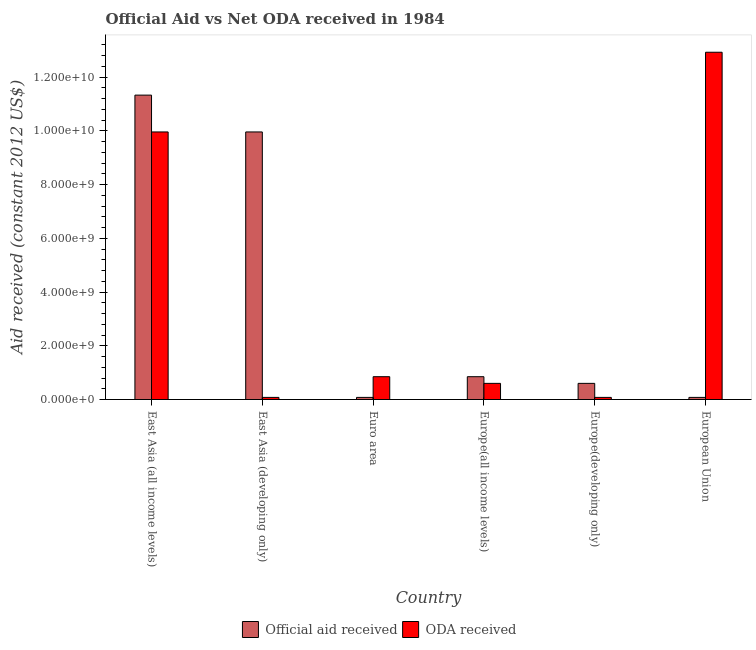How many different coloured bars are there?
Your response must be concise. 2. How many bars are there on the 4th tick from the left?
Your answer should be very brief. 2. In how many cases, is the number of bars for a given country not equal to the number of legend labels?
Make the answer very short. 0. What is the official aid received in Euro area?
Your answer should be very brief. 7.91e+07. Across all countries, what is the maximum oda received?
Your answer should be very brief. 1.29e+1. Across all countries, what is the minimum oda received?
Provide a succinct answer. 7.91e+07. In which country was the oda received maximum?
Your answer should be very brief. European Union. What is the total oda received in the graph?
Ensure brevity in your answer.  2.45e+1. What is the difference between the official aid received in East Asia (all income levels) and that in Europe(developing only)?
Keep it short and to the point. 1.07e+1. What is the average official aid received per country?
Offer a terse response. 3.82e+09. What is the difference between the official aid received and oda received in Euro area?
Offer a terse response. -7.70e+08. In how many countries, is the official aid received greater than 1600000000 US$?
Offer a terse response. 2. What is the ratio of the oda received in East Asia (developing only) to that in Europe(all income levels)?
Your answer should be very brief. 0.13. What is the difference between the highest and the second highest official aid received?
Give a very brief answer. 1.37e+09. What is the difference between the highest and the lowest oda received?
Offer a terse response. 1.28e+1. In how many countries, is the official aid received greater than the average official aid received taken over all countries?
Make the answer very short. 2. Is the sum of the oda received in East Asia (all income levels) and East Asia (developing only) greater than the maximum official aid received across all countries?
Your answer should be compact. No. What does the 2nd bar from the left in East Asia (all income levels) represents?
Provide a short and direct response. ODA received. What does the 2nd bar from the right in East Asia (developing only) represents?
Offer a very short reply. Official aid received. How many bars are there?
Your answer should be compact. 12. Are all the bars in the graph horizontal?
Your answer should be compact. No. Are the values on the major ticks of Y-axis written in scientific E-notation?
Your answer should be very brief. Yes. Does the graph contain grids?
Ensure brevity in your answer.  No. Where does the legend appear in the graph?
Offer a terse response. Bottom center. How many legend labels are there?
Offer a very short reply. 2. How are the legend labels stacked?
Your answer should be very brief. Horizontal. What is the title of the graph?
Your answer should be compact. Official Aid vs Net ODA received in 1984 . What is the label or title of the X-axis?
Your response must be concise. Country. What is the label or title of the Y-axis?
Keep it short and to the point. Aid received (constant 2012 US$). What is the Aid received (constant 2012 US$) of Official aid received in East Asia (all income levels)?
Offer a very short reply. 1.13e+1. What is the Aid received (constant 2012 US$) in ODA received in East Asia (all income levels)?
Your answer should be compact. 9.96e+09. What is the Aid received (constant 2012 US$) in Official aid received in East Asia (developing only)?
Give a very brief answer. 9.96e+09. What is the Aid received (constant 2012 US$) in ODA received in East Asia (developing only)?
Keep it short and to the point. 7.91e+07. What is the Aid received (constant 2012 US$) in Official aid received in Euro area?
Your response must be concise. 7.91e+07. What is the Aid received (constant 2012 US$) in ODA received in Euro area?
Offer a very short reply. 8.49e+08. What is the Aid received (constant 2012 US$) in Official aid received in Europe(all income levels)?
Your answer should be very brief. 8.49e+08. What is the Aid received (constant 2012 US$) of ODA received in Europe(all income levels)?
Provide a succinct answer. 6.01e+08. What is the Aid received (constant 2012 US$) of Official aid received in Europe(developing only)?
Your answer should be very brief. 6.01e+08. What is the Aid received (constant 2012 US$) in ODA received in Europe(developing only)?
Your answer should be very brief. 7.91e+07. What is the Aid received (constant 2012 US$) in Official aid received in European Union?
Your response must be concise. 7.91e+07. What is the Aid received (constant 2012 US$) in ODA received in European Union?
Ensure brevity in your answer.  1.29e+1. Across all countries, what is the maximum Aid received (constant 2012 US$) of Official aid received?
Ensure brevity in your answer.  1.13e+1. Across all countries, what is the maximum Aid received (constant 2012 US$) in ODA received?
Offer a very short reply. 1.29e+1. Across all countries, what is the minimum Aid received (constant 2012 US$) in Official aid received?
Your answer should be compact. 7.91e+07. Across all countries, what is the minimum Aid received (constant 2012 US$) of ODA received?
Ensure brevity in your answer.  7.91e+07. What is the total Aid received (constant 2012 US$) of Official aid received in the graph?
Offer a terse response. 2.29e+1. What is the total Aid received (constant 2012 US$) of ODA received in the graph?
Offer a very short reply. 2.45e+1. What is the difference between the Aid received (constant 2012 US$) in Official aid received in East Asia (all income levels) and that in East Asia (developing only)?
Give a very brief answer. 1.37e+09. What is the difference between the Aid received (constant 2012 US$) in ODA received in East Asia (all income levels) and that in East Asia (developing only)?
Your response must be concise. 9.88e+09. What is the difference between the Aid received (constant 2012 US$) of Official aid received in East Asia (all income levels) and that in Euro area?
Keep it short and to the point. 1.12e+1. What is the difference between the Aid received (constant 2012 US$) of ODA received in East Asia (all income levels) and that in Euro area?
Ensure brevity in your answer.  9.11e+09. What is the difference between the Aid received (constant 2012 US$) of Official aid received in East Asia (all income levels) and that in Europe(all income levels)?
Make the answer very short. 1.05e+1. What is the difference between the Aid received (constant 2012 US$) of ODA received in East Asia (all income levels) and that in Europe(all income levels)?
Your answer should be very brief. 9.35e+09. What is the difference between the Aid received (constant 2012 US$) of Official aid received in East Asia (all income levels) and that in Europe(developing only)?
Provide a succinct answer. 1.07e+1. What is the difference between the Aid received (constant 2012 US$) in ODA received in East Asia (all income levels) and that in Europe(developing only)?
Offer a terse response. 9.88e+09. What is the difference between the Aid received (constant 2012 US$) in Official aid received in East Asia (all income levels) and that in European Union?
Offer a terse response. 1.12e+1. What is the difference between the Aid received (constant 2012 US$) in ODA received in East Asia (all income levels) and that in European Union?
Offer a very short reply. -2.97e+09. What is the difference between the Aid received (constant 2012 US$) of Official aid received in East Asia (developing only) and that in Euro area?
Offer a very short reply. 9.88e+09. What is the difference between the Aid received (constant 2012 US$) in ODA received in East Asia (developing only) and that in Euro area?
Your response must be concise. -7.70e+08. What is the difference between the Aid received (constant 2012 US$) in Official aid received in East Asia (developing only) and that in Europe(all income levels)?
Provide a short and direct response. 9.11e+09. What is the difference between the Aid received (constant 2012 US$) in ODA received in East Asia (developing only) and that in Europe(all income levels)?
Offer a terse response. -5.22e+08. What is the difference between the Aid received (constant 2012 US$) in Official aid received in East Asia (developing only) and that in Europe(developing only)?
Your answer should be compact. 9.35e+09. What is the difference between the Aid received (constant 2012 US$) of ODA received in East Asia (developing only) and that in Europe(developing only)?
Your response must be concise. 0. What is the difference between the Aid received (constant 2012 US$) of Official aid received in East Asia (developing only) and that in European Union?
Your answer should be compact. 9.88e+09. What is the difference between the Aid received (constant 2012 US$) of ODA received in East Asia (developing only) and that in European Union?
Your answer should be compact. -1.28e+1. What is the difference between the Aid received (constant 2012 US$) of Official aid received in Euro area and that in Europe(all income levels)?
Keep it short and to the point. -7.70e+08. What is the difference between the Aid received (constant 2012 US$) in ODA received in Euro area and that in Europe(all income levels)?
Keep it short and to the point. 2.48e+08. What is the difference between the Aid received (constant 2012 US$) in Official aid received in Euro area and that in Europe(developing only)?
Your answer should be very brief. -5.22e+08. What is the difference between the Aid received (constant 2012 US$) in ODA received in Euro area and that in Europe(developing only)?
Ensure brevity in your answer.  7.70e+08. What is the difference between the Aid received (constant 2012 US$) of Official aid received in Euro area and that in European Union?
Offer a very short reply. 0. What is the difference between the Aid received (constant 2012 US$) in ODA received in Euro area and that in European Union?
Your answer should be very brief. -1.21e+1. What is the difference between the Aid received (constant 2012 US$) in Official aid received in Europe(all income levels) and that in Europe(developing only)?
Your response must be concise. 2.48e+08. What is the difference between the Aid received (constant 2012 US$) in ODA received in Europe(all income levels) and that in Europe(developing only)?
Provide a succinct answer. 5.22e+08. What is the difference between the Aid received (constant 2012 US$) in Official aid received in Europe(all income levels) and that in European Union?
Your response must be concise. 7.70e+08. What is the difference between the Aid received (constant 2012 US$) in ODA received in Europe(all income levels) and that in European Union?
Give a very brief answer. -1.23e+1. What is the difference between the Aid received (constant 2012 US$) of Official aid received in Europe(developing only) and that in European Union?
Your answer should be compact. 5.22e+08. What is the difference between the Aid received (constant 2012 US$) in ODA received in Europe(developing only) and that in European Union?
Offer a terse response. -1.28e+1. What is the difference between the Aid received (constant 2012 US$) of Official aid received in East Asia (all income levels) and the Aid received (constant 2012 US$) of ODA received in East Asia (developing only)?
Provide a short and direct response. 1.12e+1. What is the difference between the Aid received (constant 2012 US$) in Official aid received in East Asia (all income levels) and the Aid received (constant 2012 US$) in ODA received in Euro area?
Offer a terse response. 1.05e+1. What is the difference between the Aid received (constant 2012 US$) of Official aid received in East Asia (all income levels) and the Aid received (constant 2012 US$) of ODA received in Europe(all income levels)?
Your answer should be compact. 1.07e+1. What is the difference between the Aid received (constant 2012 US$) in Official aid received in East Asia (all income levels) and the Aid received (constant 2012 US$) in ODA received in Europe(developing only)?
Your answer should be very brief. 1.12e+1. What is the difference between the Aid received (constant 2012 US$) of Official aid received in East Asia (all income levels) and the Aid received (constant 2012 US$) of ODA received in European Union?
Your answer should be compact. -1.60e+09. What is the difference between the Aid received (constant 2012 US$) in Official aid received in East Asia (developing only) and the Aid received (constant 2012 US$) in ODA received in Euro area?
Your answer should be compact. 9.11e+09. What is the difference between the Aid received (constant 2012 US$) of Official aid received in East Asia (developing only) and the Aid received (constant 2012 US$) of ODA received in Europe(all income levels)?
Your response must be concise. 9.35e+09. What is the difference between the Aid received (constant 2012 US$) of Official aid received in East Asia (developing only) and the Aid received (constant 2012 US$) of ODA received in Europe(developing only)?
Give a very brief answer. 9.88e+09. What is the difference between the Aid received (constant 2012 US$) in Official aid received in East Asia (developing only) and the Aid received (constant 2012 US$) in ODA received in European Union?
Ensure brevity in your answer.  -2.97e+09. What is the difference between the Aid received (constant 2012 US$) of Official aid received in Euro area and the Aid received (constant 2012 US$) of ODA received in Europe(all income levels)?
Provide a short and direct response. -5.22e+08. What is the difference between the Aid received (constant 2012 US$) of Official aid received in Euro area and the Aid received (constant 2012 US$) of ODA received in Europe(developing only)?
Offer a very short reply. 0. What is the difference between the Aid received (constant 2012 US$) of Official aid received in Euro area and the Aid received (constant 2012 US$) of ODA received in European Union?
Provide a succinct answer. -1.28e+1. What is the difference between the Aid received (constant 2012 US$) of Official aid received in Europe(all income levels) and the Aid received (constant 2012 US$) of ODA received in Europe(developing only)?
Provide a succinct answer. 7.70e+08. What is the difference between the Aid received (constant 2012 US$) in Official aid received in Europe(all income levels) and the Aid received (constant 2012 US$) in ODA received in European Union?
Offer a terse response. -1.21e+1. What is the difference between the Aid received (constant 2012 US$) in Official aid received in Europe(developing only) and the Aid received (constant 2012 US$) in ODA received in European Union?
Your response must be concise. -1.23e+1. What is the average Aid received (constant 2012 US$) of Official aid received per country?
Provide a succinct answer. 3.82e+09. What is the average Aid received (constant 2012 US$) of ODA received per country?
Offer a very short reply. 4.08e+09. What is the difference between the Aid received (constant 2012 US$) of Official aid received and Aid received (constant 2012 US$) of ODA received in East Asia (all income levels)?
Offer a very short reply. 1.37e+09. What is the difference between the Aid received (constant 2012 US$) of Official aid received and Aid received (constant 2012 US$) of ODA received in East Asia (developing only)?
Keep it short and to the point. 9.88e+09. What is the difference between the Aid received (constant 2012 US$) in Official aid received and Aid received (constant 2012 US$) in ODA received in Euro area?
Provide a short and direct response. -7.70e+08. What is the difference between the Aid received (constant 2012 US$) of Official aid received and Aid received (constant 2012 US$) of ODA received in Europe(all income levels)?
Give a very brief answer. 2.48e+08. What is the difference between the Aid received (constant 2012 US$) in Official aid received and Aid received (constant 2012 US$) in ODA received in Europe(developing only)?
Ensure brevity in your answer.  5.22e+08. What is the difference between the Aid received (constant 2012 US$) in Official aid received and Aid received (constant 2012 US$) in ODA received in European Union?
Offer a terse response. -1.28e+1. What is the ratio of the Aid received (constant 2012 US$) of Official aid received in East Asia (all income levels) to that in East Asia (developing only)?
Give a very brief answer. 1.14. What is the ratio of the Aid received (constant 2012 US$) of ODA received in East Asia (all income levels) to that in East Asia (developing only)?
Give a very brief answer. 125.87. What is the ratio of the Aid received (constant 2012 US$) of Official aid received in East Asia (all income levels) to that in Euro area?
Ensure brevity in your answer.  143.19. What is the ratio of the Aid received (constant 2012 US$) in ODA received in East Asia (all income levels) to that in Euro area?
Your response must be concise. 11.73. What is the ratio of the Aid received (constant 2012 US$) in Official aid received in East Asia (all income levels) to that in Europe(all income levels)?
Your answer should be very brief. 13.34. What is the ratio of the Aid received (constant 2012 US$) of ODA received in East Asia (all income levels) to that in Europe(all income levels)?
Your answer should be very brief. 16.56. What is the ratio of the Aid received (constant 2012 US$) in Official aid received in East Asia (all income levels) to that in Europe(developing only)?
Your response must be concise. 18.84. What is the ratio of the Aid received (constant 2012 US$) of ODA received in East Asia (all income levels) to that in Europe(developing only)?
Provide a short and direct response. 125.87. What is the ratio of the Aid received (constant 2012 US$) in Official aid received in East Asia (all income levels) to that in European Union?
Offer a terse response. 143.19. What is the ratio of the Aid received (constant 2012 US$) in ODA received in East Asia (all income levels) to that in European Union?
Give a very brief answer. 0.77. What is the ratio of the Aid received (constant 2012 US$) in Official aid received in East Asia (developing only) to that in Euro area?
Offer a terse response. 125.87. What is the ratio of the Aid received (constant 2012 US$) of ODA received in East Asia (developing only) to that in Euro area?
Offer a very short reply. 0.09. What is the ratio of the Aid received (constant 2012 US$) in Official aid received in East Asia (developing only) to that in Europe(all income levels)?
Make the answer very short. 11.73. What is the ratio of the Aid received (constant 2012 US$) of ODA received in East Asia (developing only) to that in Europe(all income levels)?
Your answer should be very brief. 0.13. What is the ratio of the Aid received (constant 2012 US$) of Official aid received in East Asia (developing only) to that in Europe(developing only)?
Your response must be concise. 16.56. What is the ratio of the Aid received (constant 2012 US$) of ODA received in East Asia (developing only) to that in Europe(developing only)?
Ensure brevity in your answer.  1. What is the ratio of the Aid received (constant 2012 US$) in Official aid received in East Asia (developing only) to that in European Union?
Your answer should be very brief. 125.87. What is the ratio of the Aid received (constant 2012 US$) of ODA received in East Asia (developing only) to that in European Union?
Ensure brevity in your answer.  0.01. What is the ratio of the Aid received (constant 2012 US$) of Official aid received in Euro area to that in Europe(all income levels)?
Provide a succinct answer. 0.09. What is the ratio of the Aid received (constant 2012 US$) in ODA received in Euro area to that in Europe(all income levels)?
Make the answer very short. 1.41. What is the ratio of the Aid received (constant 2012 US$) in Official aid received in Euro area to that in Europe(developing only)?
Provide a succinct answer. 0.13. What is the ratio of the Aid received (constant 2012 US$) in ODA received in Euro area to that in Europe(developing only)?
Give a very brief answer. 10.73. What is the ratio of the Aid received (constant 2012 US$) of ODA received in Euro area to that in European Union?
Your answer should be very brief. 0.07. What is the ratio of the Aid received (constant 2012 US$) of Official aid received in Europe(all income levels) to that in Europe(developing only)?
Keep it short and to the point. 1.41. What is the ratio of the Aid received (constant 2012 US$) of ODA received in Europe(all income levels) to that in Europe(developing only)?
Keep it short and to the point. 7.6. What is the ratio of the Aid received (constant 2012 US$) of Official aid received in Europe(all income levels) to that in European Union?
Offer a very short reply. 10.73. What is the ratio of the Aid received (constant 2012 US$) in ODA received in Europe(all income levels) to that in European Union?
Provide a succinct answer. 0.05. What is the ratio of the Aid received (constant 2012 US$) of Official aid received in Europe(developing only) to that in European Union?
Keep it short and to the point. 7.6. What is the ratio of the Aid received (constant 2012 US$) of ODA received in Europe(developing only) to that in European Union?
Provide a succinct answer. 0.01. What is the difference between the highest and the second highest Aid received (constant 2012 US$) in Official aid received?
Give a very brief answer. 1.37e+09. What is the difference between the highest and the second highest Aid received (constant 2012 US$) in ODA received?
Offer a very short reply. 2.97e+09. What is the difference between the highest and the lowest Aid received (constant 2012 US$) in Official aid received?
Offer a very short reply. 1.12e+1. What is the difference between the highest and the lowest Aid received (constant 2012 US$) of ODA received?
Provide a succinct answer. 1.28e+1. 